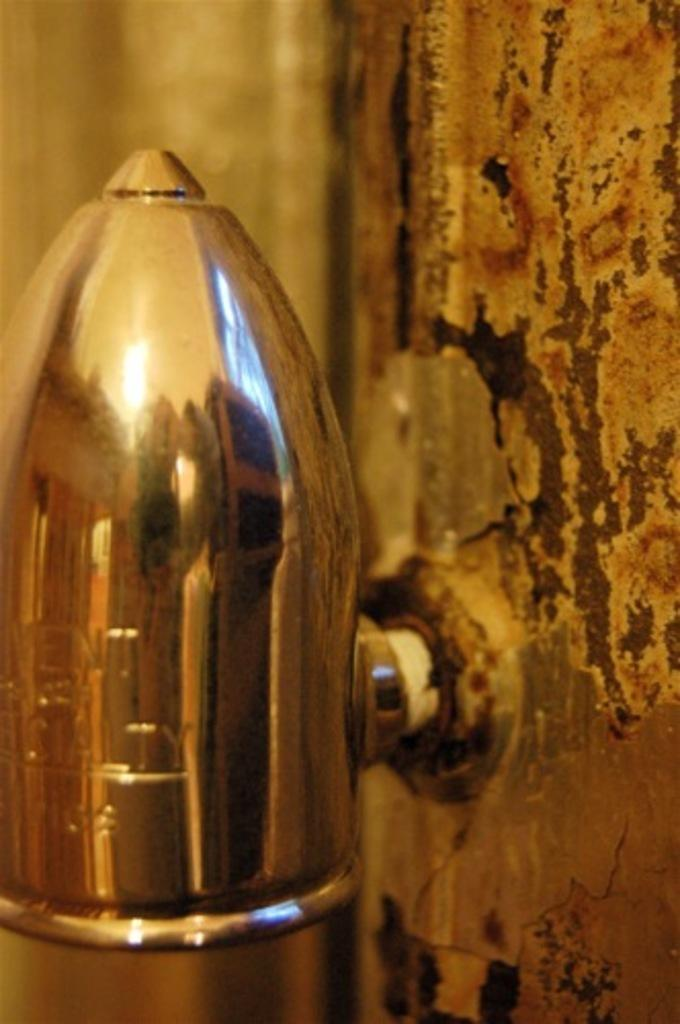What is the object that is fitted to the wall in the image? Unfortunately, the provided facts do not specify the type of object that is fitted to the wall. What type of yarn is being used to make the shirt in the image? There is no shirt or yarn present in the image. 